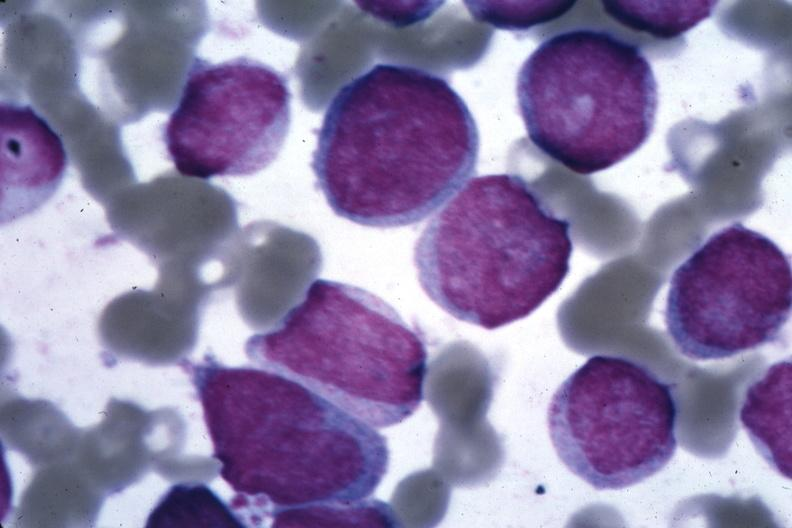does bone, clivus show oil wrights cells easily diagnosed?
Answer the question using a single word or phrase. No 